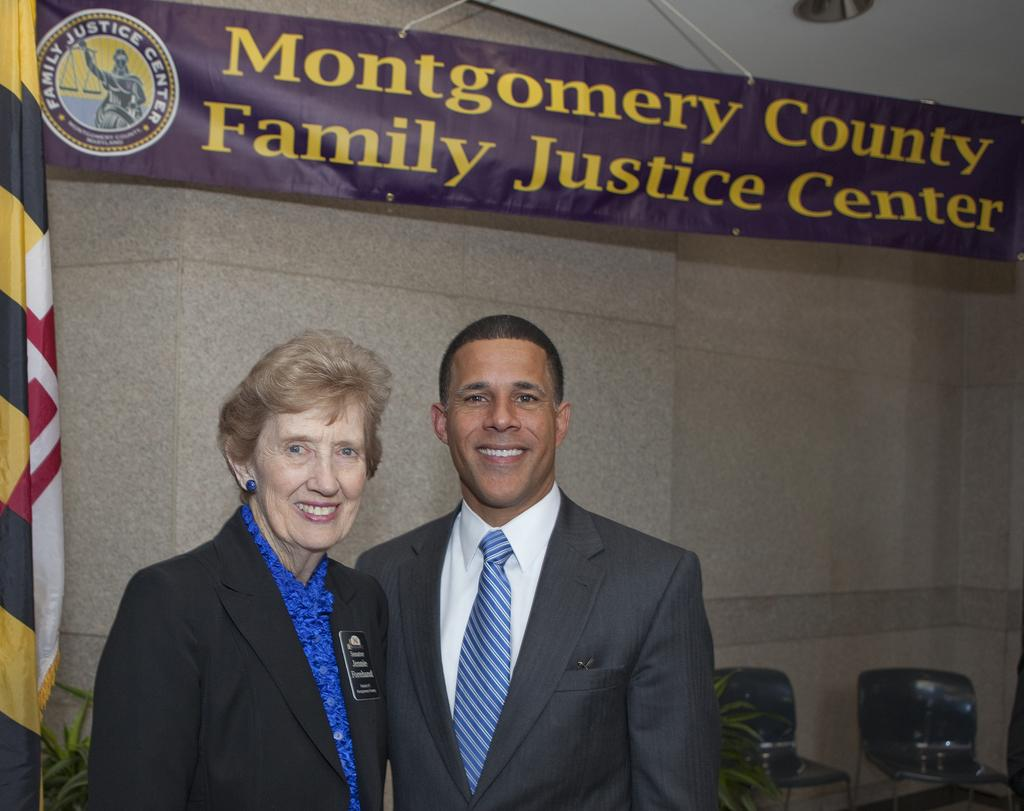How many people are present in the image? There are two people standing in the image. What type of vegetation can be seen in the image? There are house plants visible in the image. What type of furniture is present in the image? There are chairs in the image. What is the background of the image made of? There is a wall in the image. What additional decoration or signage is present in the image? There is a banner in the image. What is the limit of the banner in the image? The limit of the banner is not mentioned in the image, as it does not refer to any restrictions or boundaries. 